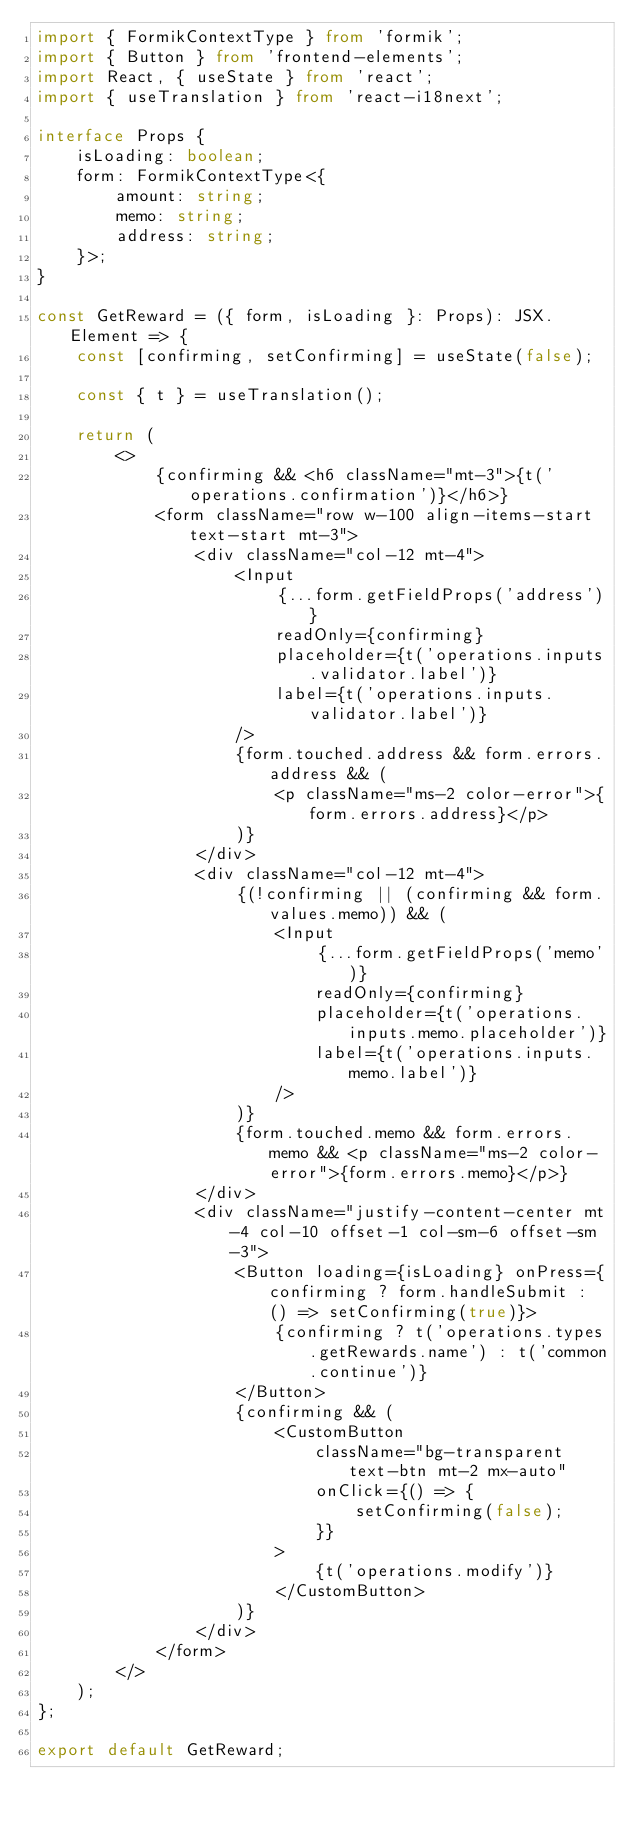Convert code to text. <code><loc_0><loc_0><loc_500><loc_500><_TypeScript_>import { FormikContextType } from 'formik';
import { Button } from 'frontend-elements';
import React, { useState } from 'react';
import { useTranslation } from 'react-i18next';

interface Props {
    isLoading: boolean;
    form: FormikContextType<{
        amount: string;
        memo: string;
        address: string;
    }>;
}

const GetReward = ({ form, isLoading }: Props): JSX.Element => {
    const [confirming, setConfirming] = useState(false);

    const { t } = useTranslation();

    return (
        <>
            {confirming && <h6 className="mt-3">{t('operations.confirmation')}</h6>}
            <form className="row w-100 align-items-start text-start mt-3">
                <div className="col-12 mt-4">
                    <Input
                        {...form.getFieldProps('address')}
                        readOnly={confirming}
                        placeholder={t('operations.inputs.validator.label')}
                        label={t('operations.inputs.validator.label')}
                    />
                    {form.touched.address && form.errors.address && (
                        <p className="ms-2 color-error">{form.errors.address}</p>
                    )}
                </div>
                <div className="col-12 mt-4">
                    {(!confirming || (confirming && form.values.memo)) && (
                        <Input
                            {...form.getFieldProps('memo')}
                            readOnly={confirming}
                            placeholder={t('operations.inputs.memo.placeholder')}
                            label={t('operations.inputs.memo.label')}
                        />
                    )}
                    {form.touched.memo && form.errors.memo && <p className="ms-2 color-error">{form.errors.memo}</p>}
                </div>
                <div className="justify-content-center mt-4 col-10 offset-1 col-sm-6 offset-sm-3">
                    <Button loading={isLoading} onPress={confirming ? form.handleSubmit : () => setConfirming(true)}>
                        {confirming ? t('operations.types.getRewards.name') : t('common.continue')}
                    </Button>
                    {confirming && (
                        <CustomButton
                            className="bg-transparent text-btn mt-2 mx-auto"
                            onClick={() => {
                                setConfirming(false);
                            }}
                        >
                            {t('operations.modify')}
                        </CustomButton>
                    )}
                </div>
            </form>
        </>
    );
};

export default GetReward;
</code> 